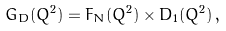<formula> <loc_0><loc_0><loc_500><loc_500>G _ { D } ( Q ^ { 2 } ) = F _ { N } ( Q ^ { 2 } ) \times D _ { 1 } ( Q ^ { 2 } ) \, ,</formula> 